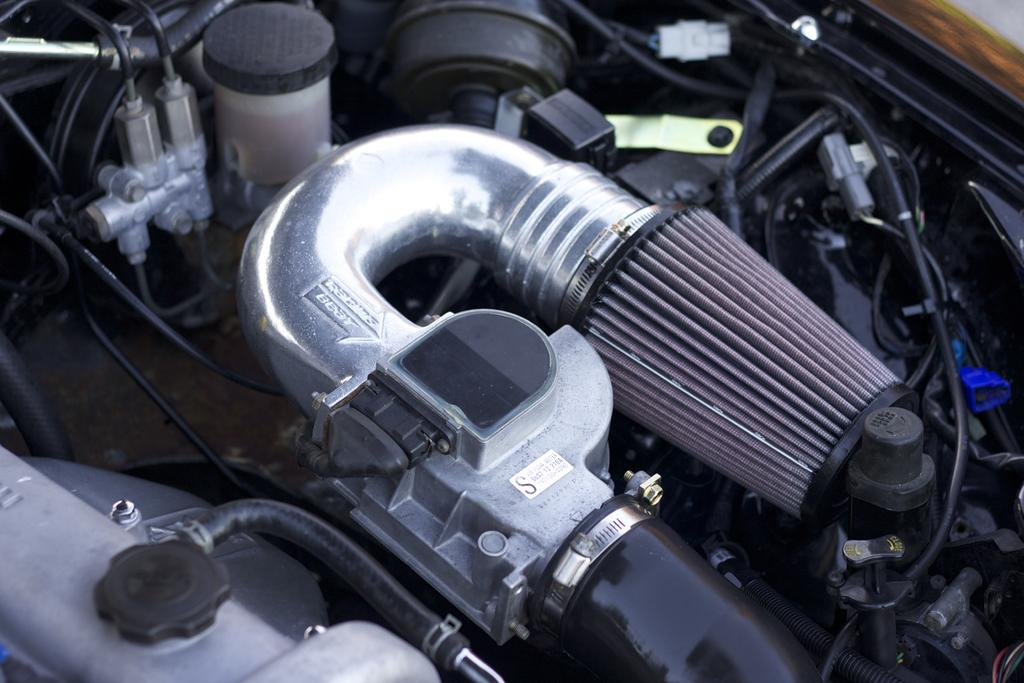What is the main subject of the image? The main subject of the image seems to depict an engine of a vehicle. Can you tell me where the seashore is located in the image? There is no seashore present in the image; it features an engine of a vehicle. What type of government is depicted in the image? There is no government depicted in the image; it features an engine of a vehicle. 